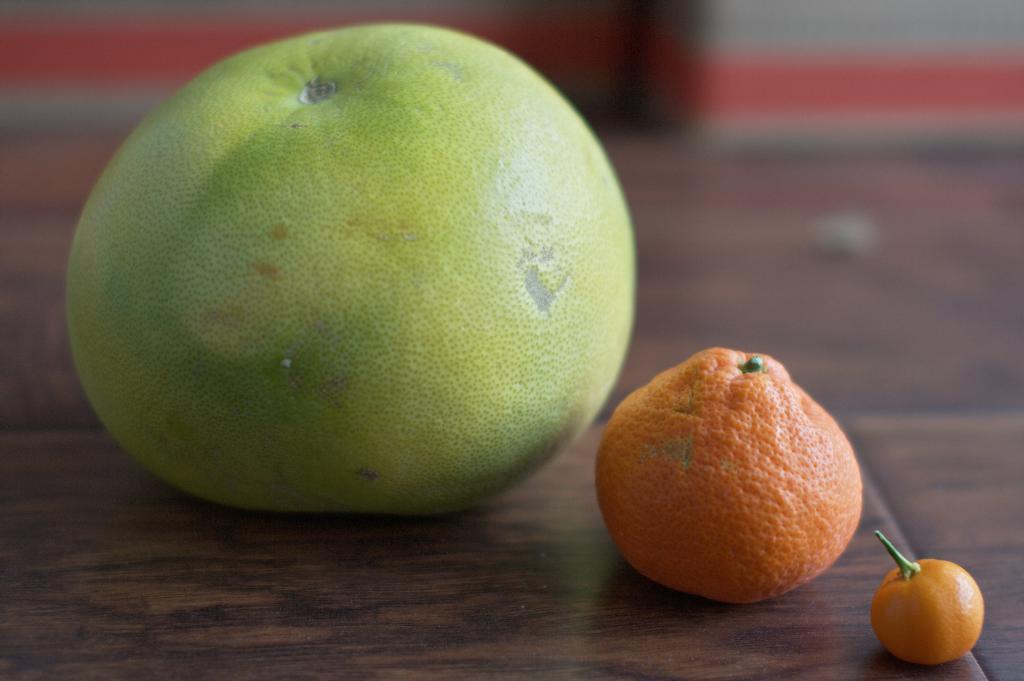Please provide a concise description of this image. In this picture we can see few fruits and blurry background. 